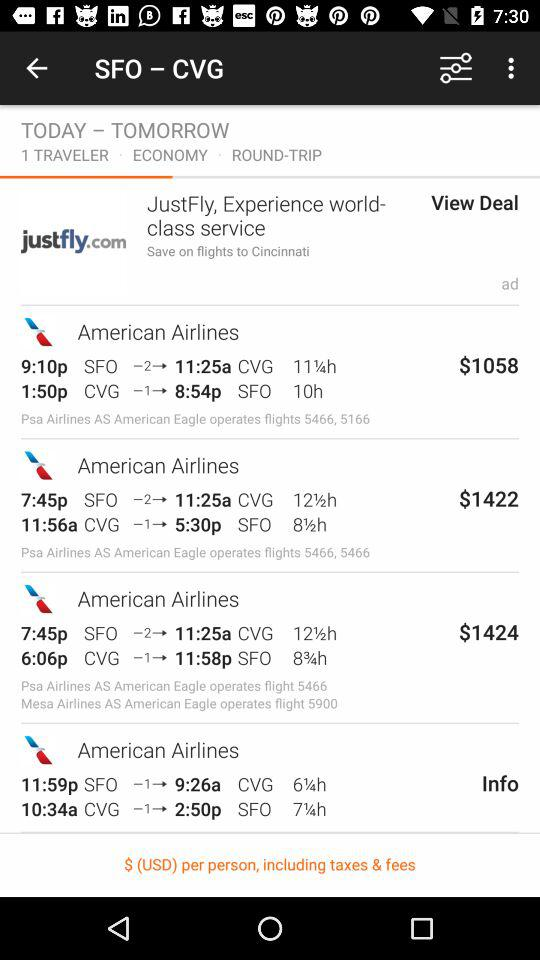What are the two stations' names? The stations' names are "SFO" and "CVG". 